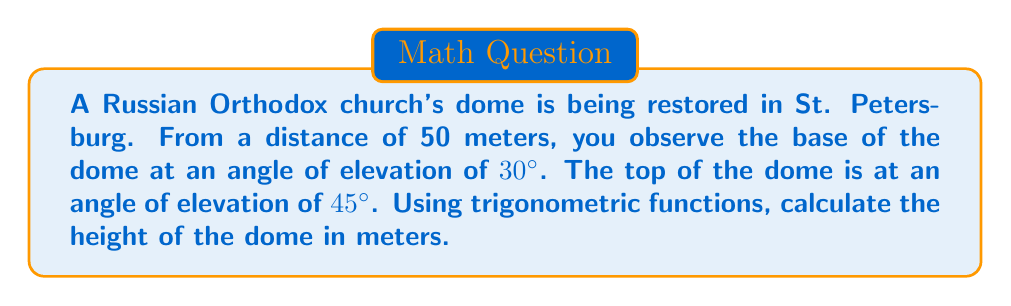Teach me how to tackle this problem. Let's approach this step-by-step:

1) Let's define our variables:
   $h$ = height of the dome
   $d$ = distance to the church (50 meters)
   $x$ = height from the ground to the base of the dome

2) We can create two right triangles:
   - One from the ground to the base of the dome
   - Another from the base of the dome to its top

3) For the first triangle (to the base of the dome):
   $\tan 30° = \frac{x}{d}$
   $x = d \tan 30°$
   $x = 50 \tan 30°$
   $x = 50 \cdot \frac{1}{\sqrt{3}} \approx 28.87$ meters

4) For the second triangle (from base to top of dome):
   $\tan 45° = \frac{h}{d}$
   $h = d \tan 45°$
   $h = 50 \tan 45°$
   $h = 50 \cdot 1 = 50$ meters

5) The height of the dome is the difference between these two heights:
   Dome height = $h - x$
   $= 50 - 28.87$
   $\approx 21.13$ meters

[asy]
import geometry;

size(200);
pair A=(0,0), B=(50,0), C=(50,28.87), D=(50,50);
draw(A--B--D--A);
draw(B--C);
label("50m", B, S);
label("28.87m", (50,14), E);
label("21.13m", (50,39), E);
label("30°", A, NE);
label("45°", A, N);
label("Ground", (25,0), S);
dot("A", A, SW);
dot("B", B, SE);
dot("C", C, E);
dot("D", D, NE);
[/asy]
Answer: $$21.13 \text{ meters}$$ 